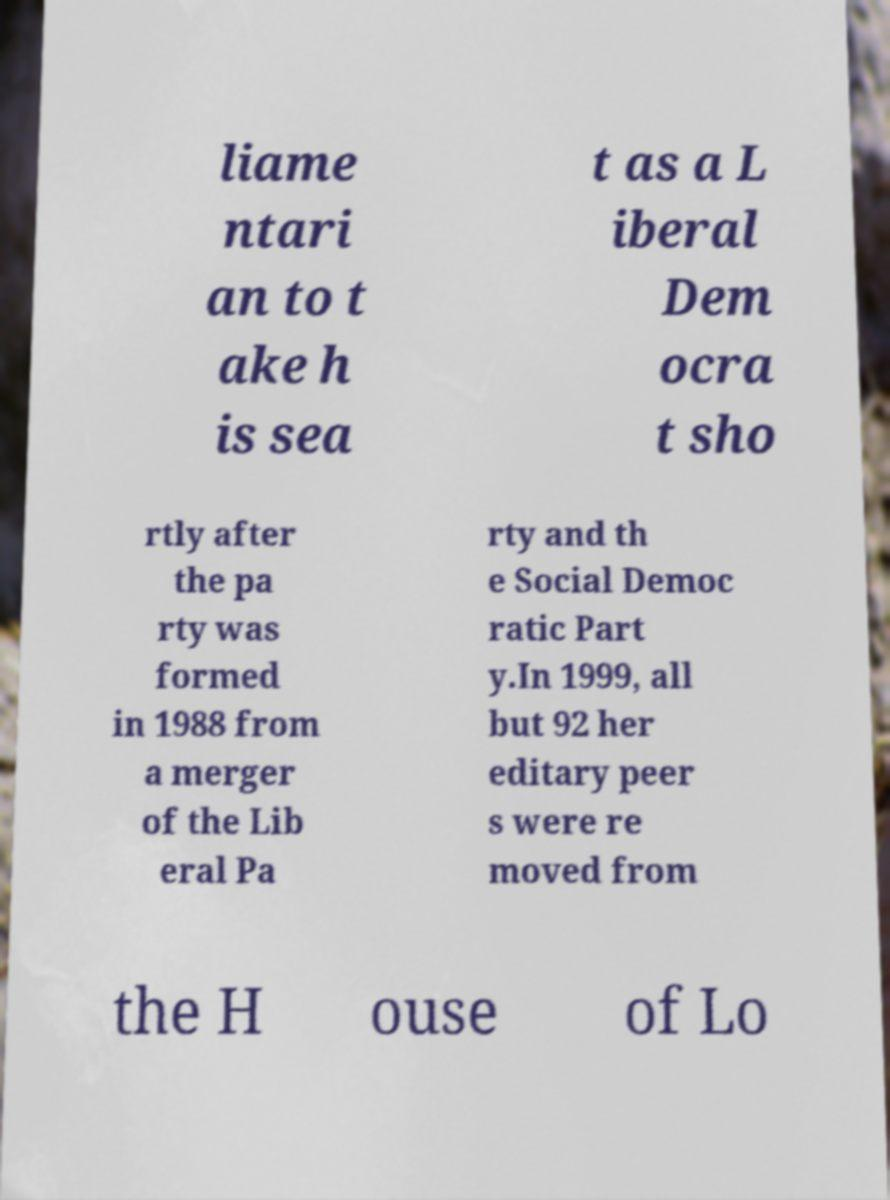Please identify and transcribe the text found in this image. liame ntari an to t ake h is sea t as a L iberal Dem ocra t sho rtly after the pa rty was formed in 1988 from a merger of the Lib eral Pa rty and th e Social Democ ratic Part y.In 1999, all but 92 her editary peer s were re moved from the H ouse of Lo 